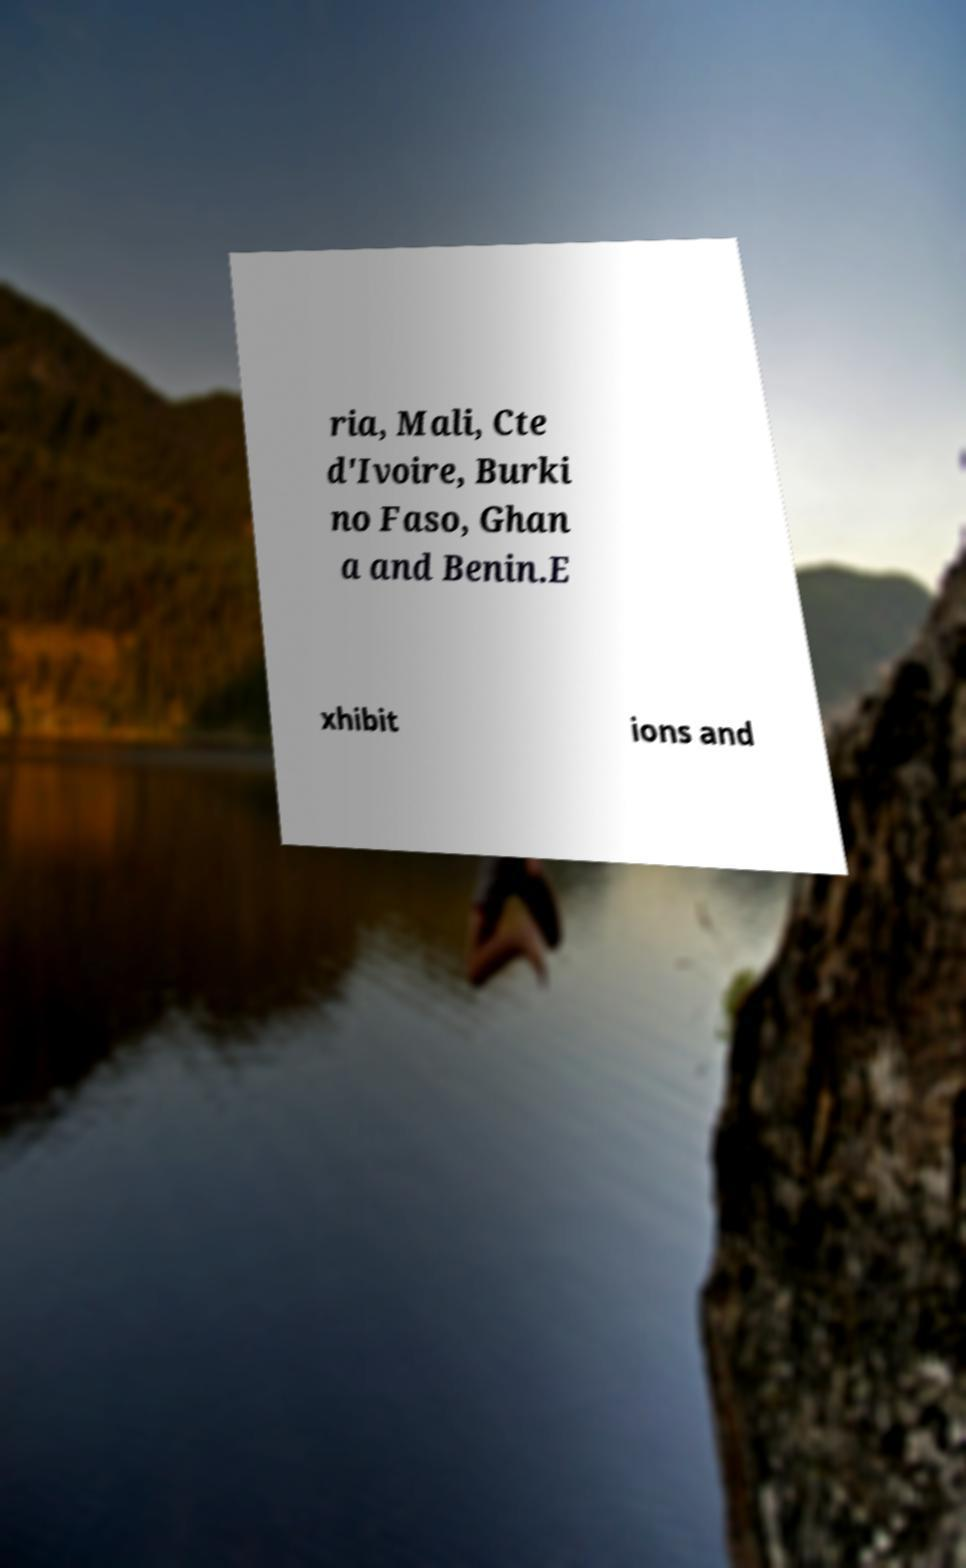Could you extract and type out the text from this image? ria, Mali, Cte d'Ivoire, Burki no Faso, Ghan a and Benin.E xhibit ions and 